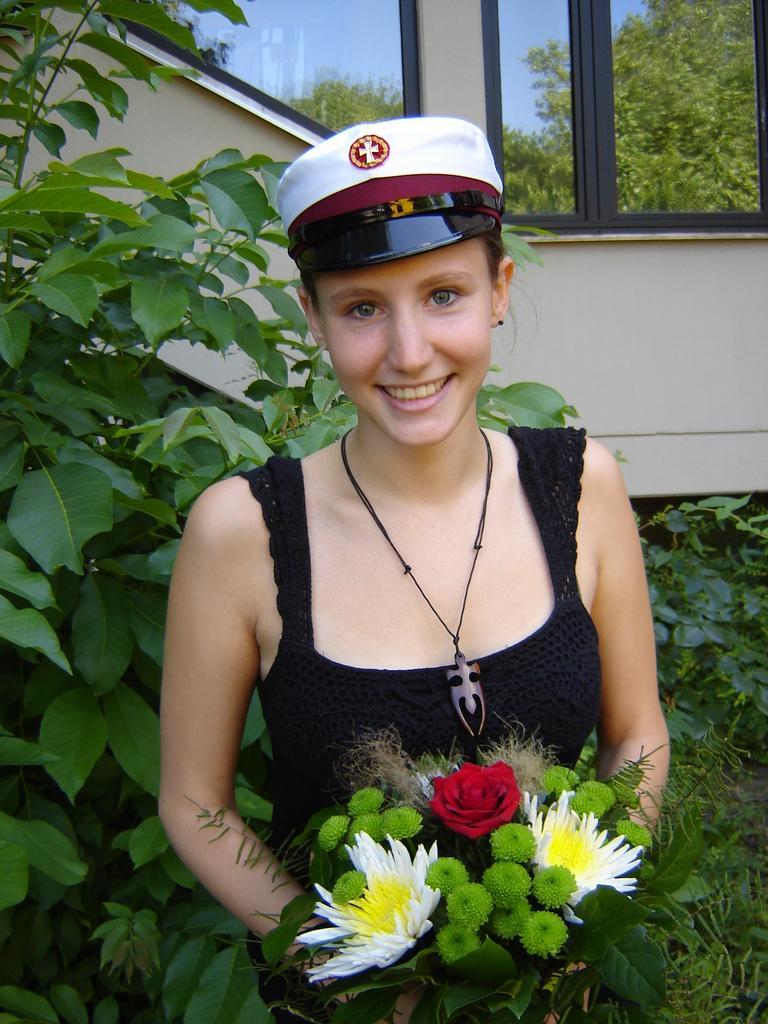Can you describe this image briefly? A woman is holding flowers, these are trees and this is glass. 